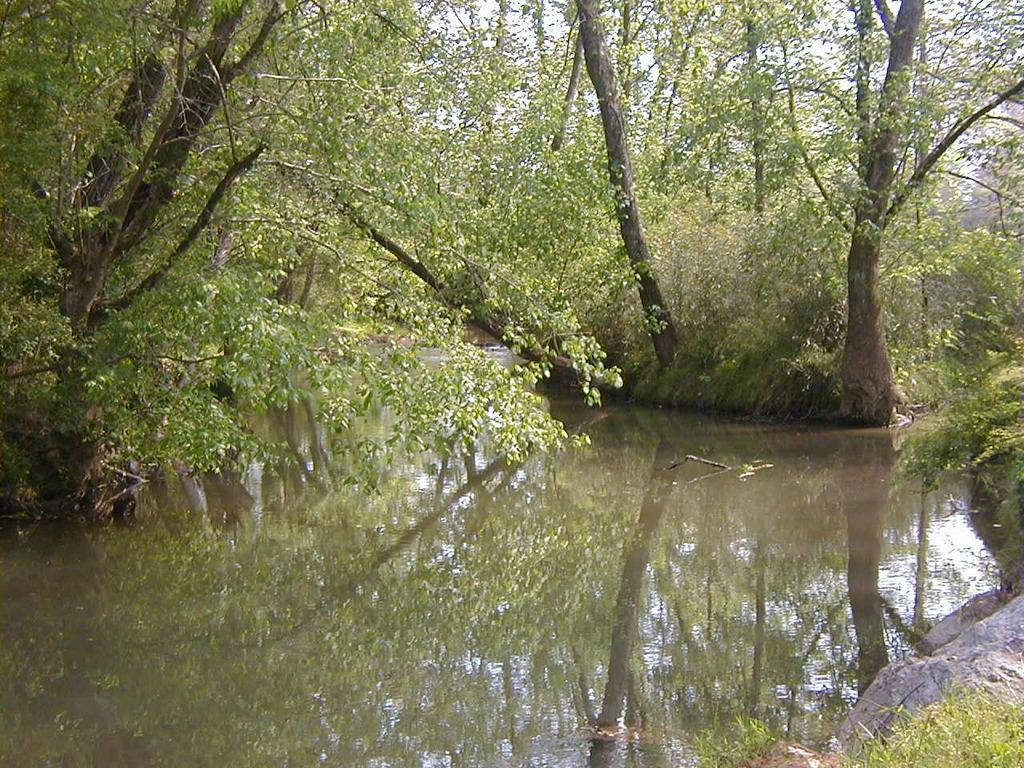What type of natural environment is depicted in the image? There is a forest in the image. Are there any water features in the forest? Yes, there is a body of water near the trees in the forest. What types of vegetation can be seen in the forest? Plants are present in the forest. What other geological features can be seen in the forest? Rocks are visible in the forest. What part of the sky is visible in the image? The sky is visible in some parts of the image. What type of support does the governor provide for the trees in the image? There is no governor present in the image, and therefore no support can be provided. 